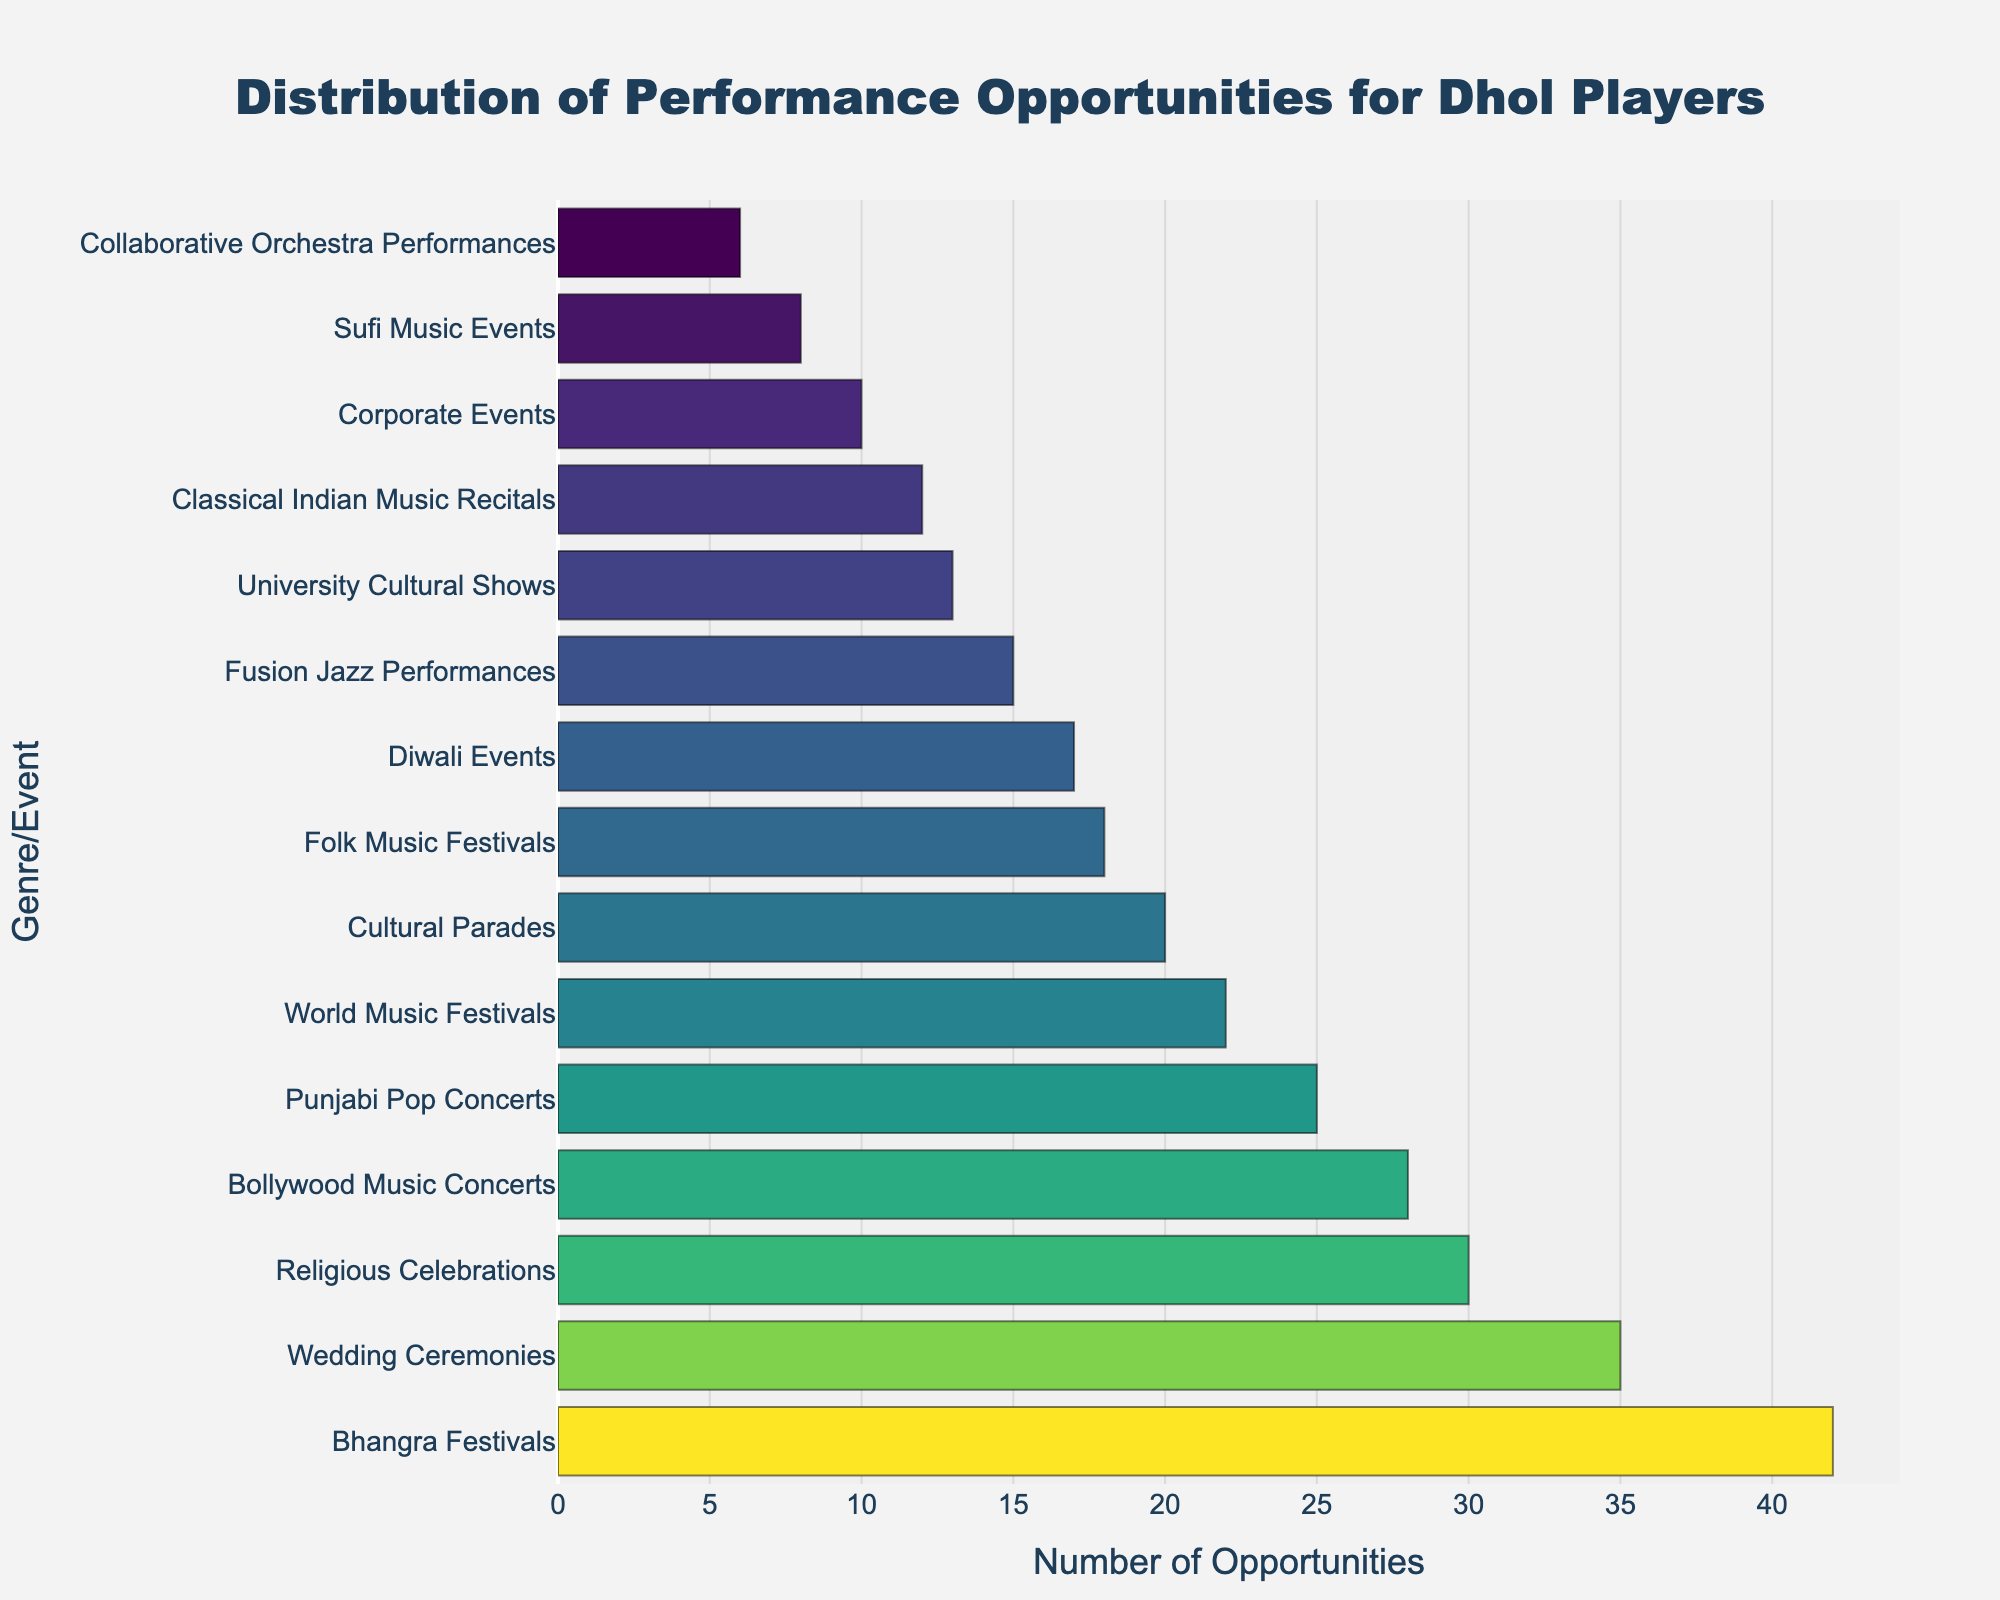Which Genre/Event has the highest number of performance opportunities for dhol players? By looking at the length of the bars, we can see that "Bhangra Festivals" has the longest bar, indicating it has the highest number of performance opportunities.
Answer: Bhangra Festivals Which two genres/events have the least number of performance opportunities, and what are their values? By examining the chart, the two genres/events with the shortest bars are "Collaborative Orchestra Performances" and "Sufi Music Events." The corresponding performance opportunities are 6 and 8, respectively.
Answer: Collaborative Orchestra Performances: 6, Sufi Music Events: 8 How many more performance opportunities are there at Wedding Ceremonies compared to Classical Indian Music Recitals? The number of performance opportunities at Wedding Ceremonies is 35, and at Classical Indian Music Recitals, it is 12. Subtracting these two values gives 35 - 12 = 23.
Answer: 23 What is the combined number of performance opportunities for World Music Festivals and Diwali Events? The number of performance opportunities for World Music Festivals is 22, and for Diwali Events, it's 17. Adding these values together results in 22 + 17 = 39.
Answer: 39 Are there more performance opportunities at Bollywood Music Concerts or Punjabi Pop Concerts? The number of performance opportunities at Bollywood Music Concerts is 28, and for Punjabi Pop Concerts, it is 25. Comparing these values, 28 is greater than 25.
Answer: Bollywood Music Concerts What is the average number of performance opportunities across Classical Indian Music Recitals, Fusion Jazz Performances, and University Cultural Shows? The performance opportunities for these three are 12 (Classical Indian Music Recitals), 15 (Fusion Jazz Performances), and 13 (University Cultural Shows). Summing these values gives 12 + 15 + 13 = 40. The average is 40 / 3 ≈ 13.33
Answer: 13.33 Which event has a smaller number of performance opportunities: Cultural Parades or Religious Celebrations? The number of performance opportunities for Cultural Parades is 20, and for Religious Celebrations, it is 30. Since 20 is less than 30, Cultural Parades has fewer opportunities.
Answer: Cultural Parades What is the difference in the number of performance opportunities between the highest and the lowest events? The highest number of performance opportunities is 42 (Bhangra Festivals), and the lowest is 6 (Collaborative Orchestra Performances). Subtracting these gives 42 - 6 = 36.
Answer: 36 If you sum the performance opportunities for three events with the highest opportunities, what is the result? The three events with the highest opportunities are Bhangra Festivals (42), Wedding Ceremonies (35), and Religious Celebrations (30). Summing these gives 42 + 35 + 30 = 107.
Answer: 107 Which event has a performance opportunity number closest to 20, and what is the exact number? Cultural Parades have a performance opportunity number of 20, which is exactly equal to 20.
Answer: Cultural Parades: 20 